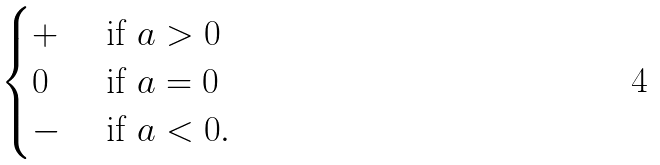<formula> <loc_0><loc_0><loc_500><loc_500>\begin{cases} + & \text { if $a>0$} \\ 0 & \text { if $a=0$} \\ - & \text { if $a<0$} . \\ \end{cases}</formula> 